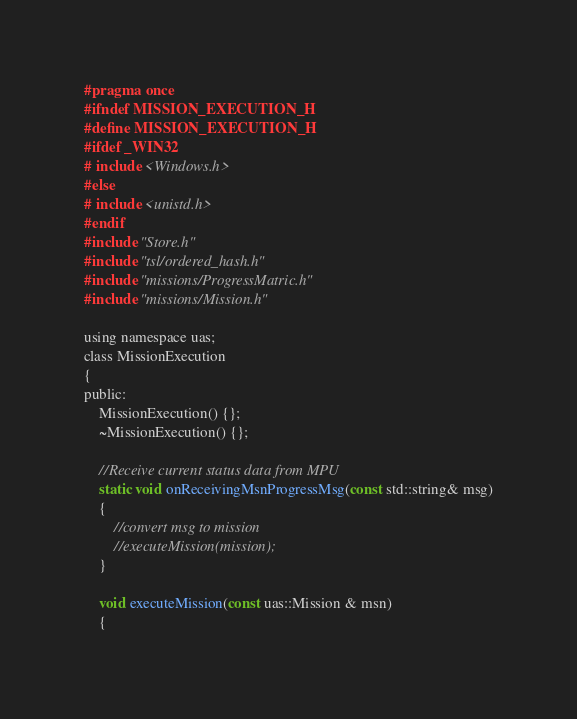<code> <loc_0><loc_0><loc_500><loc_500><_C_>#pragma once
#ifndef MISSION_EXECUTION_H
#define MISSION_EXECUTION_H
#ifdef _WIN32
# include <Windows.h>
#else
# include <unistd.h>
#endif
#include "Store.h"
#include "tsl/ordered_hash.h"
#include "missions/ProgressMatric.h"
#include "missions/Mission.h"

using namespace uas;
class MissionExecution
{
public:
	MissionExecution() {};
	~MissionExecution() {};

	//Receive current status data from MPU 
	static void onReceivingMsnProgressMsg(const std::string& msg)
	{
		//convert msg to mission 
		//executeMission(mission);
	}

	void executeMission(const uas::Mission & msn)
	{</code> 